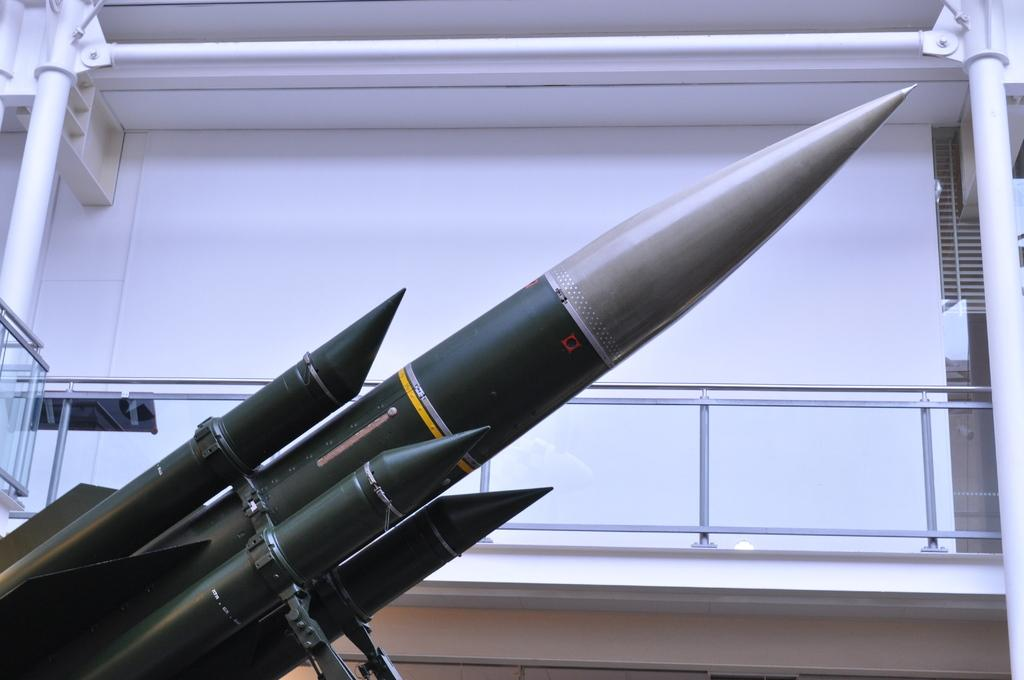What is the main subject of the image? The main subject of the image is a missile. What can be seen in the background of the image? There is a building in the background of the image. Can you describe the building in the image? The building has rods and a glass element. How many rabbits can be seen playing in the snow near the missile in the image? There are no rabbits or snow present in the image; it features a missile and a building in the background. 